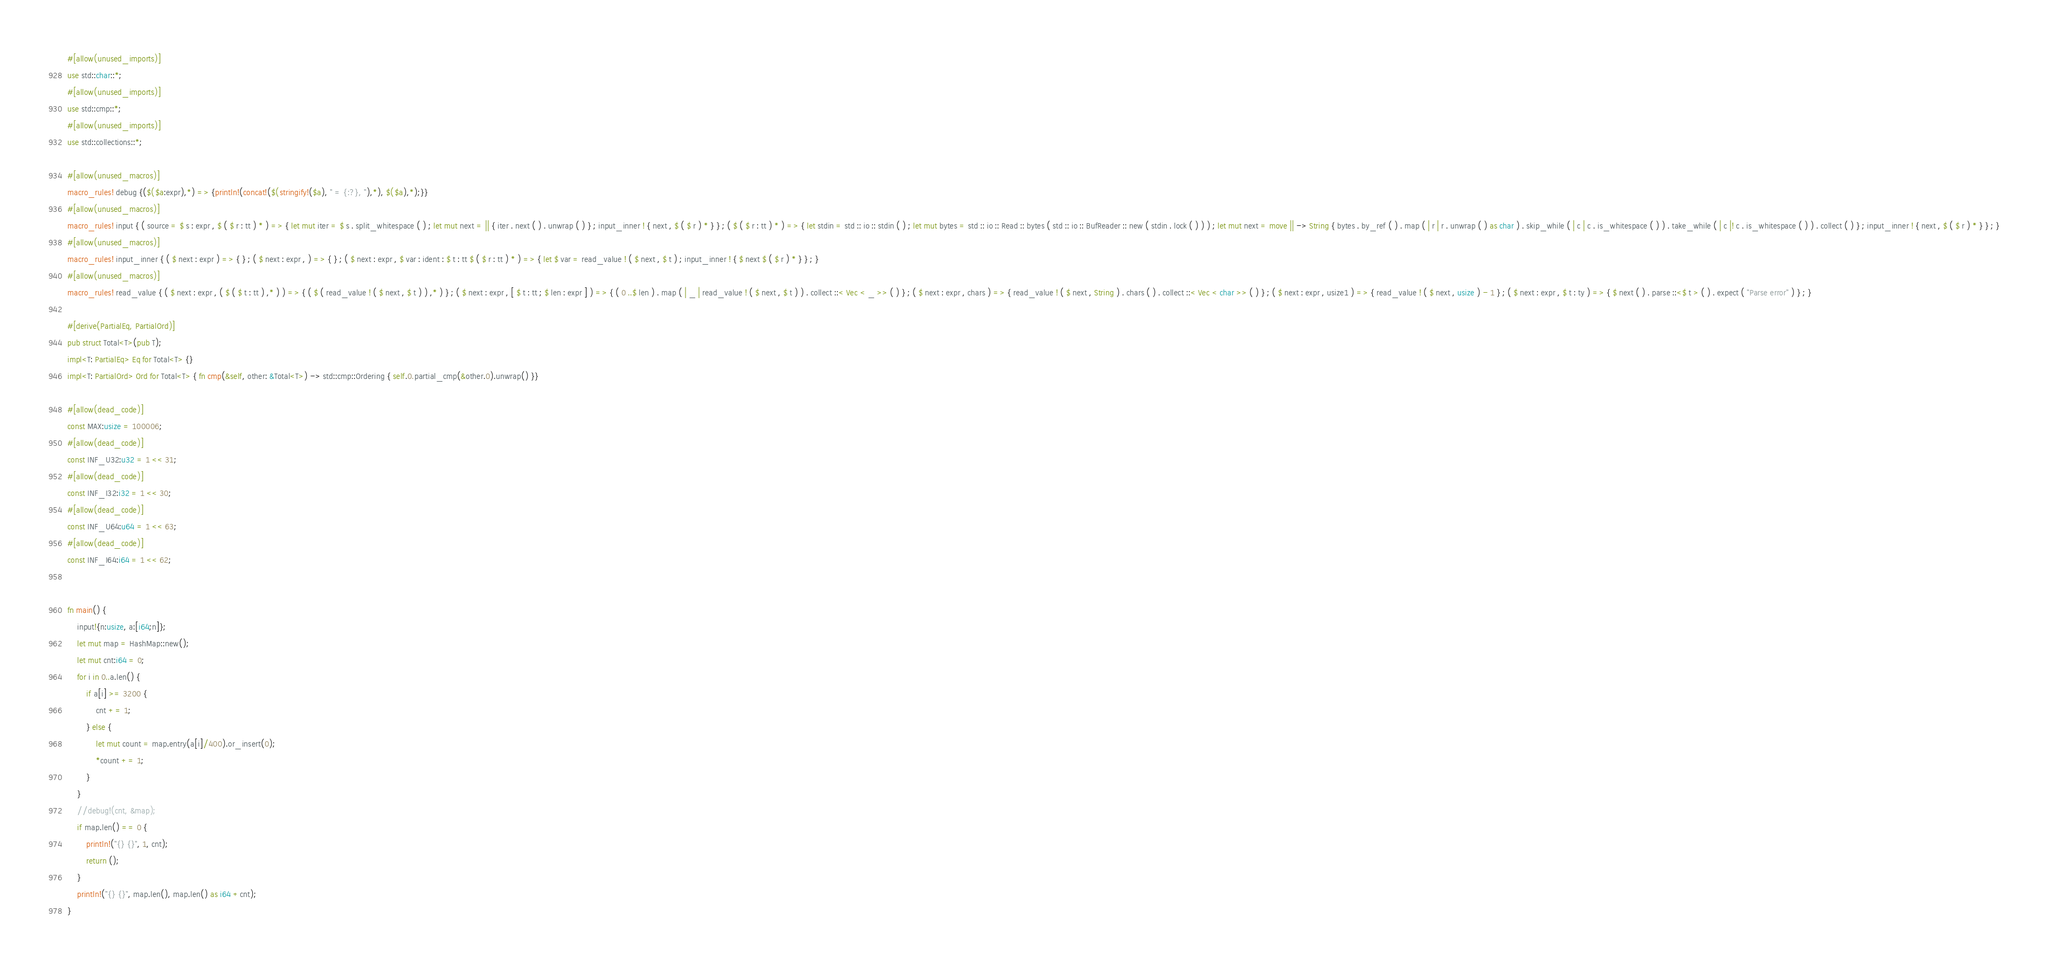<code> <loc_0><loc_0><loc_500><loc_500><_Rust_>#[allow(unused_imports)]
use std::char::*;
#[allow(unused_imports)]
use std::cmp::*;
#[allow(unused_imports)]
use std::collections::*;

#[allow(unused_macros)]
macro_rules! debug {($($a:expr),*) => {println!(concat!($(stringify!($a), " = {:?}, "),*), $($a),*);}}
#[allow(unused_macros)]
macro_rules! input { ( source = $ s : expr , $ ( $ r : tt ) * ) => { let mut iter = $ s . split_whitespace ( ) ; let mut next = || { iter . next ( ) . unwrap ( ) } ; input_inner ! { next , $ ( $ r ) * } } ; ( $ ( $ r : tt ) * ) => { let stdin = std :: io :: stdin ( ) ; let mut bytes = std :: io :: Read :: bytes ( std :: io :: BufReader :: new ( stdin . lock ( ) ) ) ; let mut next = move || -> String { bytes . by_ref ( ) . map ( | r | r . unwrap ( ) as char ) . skip_while ( | c | c . is_whitespace ( ) ) . take_while ( | c |! c . is_whitespace ( ) ) . collect ( ) } ; input_inner ! { next , $ ( $ r ) * } } ; }
#[allow(unused_macros)]
macro_rules! input_inner { ( $ next : expr ) => { } ; ( $ next : expr , ) => { } ; ( $ next : expr , $ var : ident : $ t : tt $ ( $ r : tt ) * ) => { let $ var = read_value ! ( $ next , $ t ) ; input_inner ! { $ next $ ( $ r ) * } } ; }
#[allow(unused_macros)]
macro_rules! read_value { ( $ next : expr , ( $ ( $ t : tt ) ,* ) ) => { ( $ ( read_value ! ( $ next , $ t ) ) ,* ) } ; ( $ next : expr , [ $ t : tt ; $ len : expr ] ) => { ( 0 ..$ len ) . map ( | _ | read_value ! ( $ next , $ t ) ) . collect ::< Vec < _ >> ( ) } ; ( $ next : expr , chars ) => { read_value ! ( $ next , String ) . chars ( ) . collect ::< Vec < char >> ( ) } ; ( $ next : expr , usize1 ) => { read_value ! ( $ next , usize ) - 1 } ; ( $ next : expr , $ t : ty ) => { $ next ( ) . parse ::<$ t > ( ) . expect ( "Parse error" ) } ; }

#[derive(PartialEq, PartialOrd)]
pub struct Total<T>(pub T);
impl<T: PartialEq> Eq for Total<T> {}
impl<T: PartialOrd> Ord for Total<T> { fn cmp(&self, other: &Total<T>) -> std::cmp::Ordering { self.0.partial_cmp(&other.0).unwrap() }}

#[allow(dead_code)]
const MAX:usize = 100006;
#[allow(dead_code)]
const INF_U32:u32 = 1 << 31;
#[allow(dead_code)]
const INF_I32:i32 = 1 << 30;
#[allow(dead_code)]
const INF_U64:u64 = 1 << 63;
#[allow(dead_code)]
const INF_I64:i64 = 1 << 62;


fn main() {
    input!{n:usize, a:[i64;n]};
    let mut map = HashMap::new();
    let mut cnt:i64 = 0;
    for i in 0..a.len() {
        if a[i] >= 3200 {
            cnt += 1;
        } else {
            let mut count = map.entry(a[i]/400).or_insert(0);
            *count += 1;
        }
    }
    //debug!(cnt, &map);
    if map.len() == 0 {
        println!("{} {}", 1, cnt);
        return ();
    }
    println!("{} {}", map.len(), map.len() as i64 +cnt);
}
</code> 